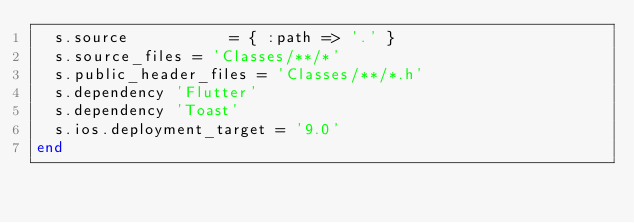<code> <loc_0><loc_0><loc_500><loc_500><_Ruby_>  s.source           = { :path => '.' }
  s.source_files = 'Classes/**/*'
  s.public_header_files = 'Classes/**/*.h'
  s.dependency 'Flutter'
  s.dependency 'Toast'
  s.ios.deployment_target = '9.0'
end

</code> 